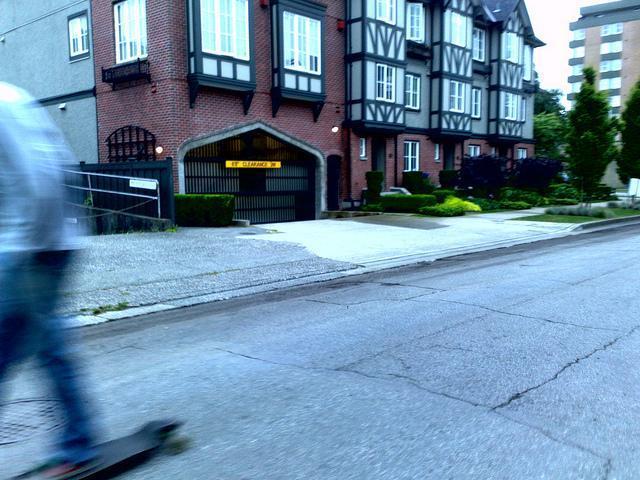How many skateboards can be seen?
Give a very brief answer. 1. How many cows are there?
Give a very brief answer. 0. 